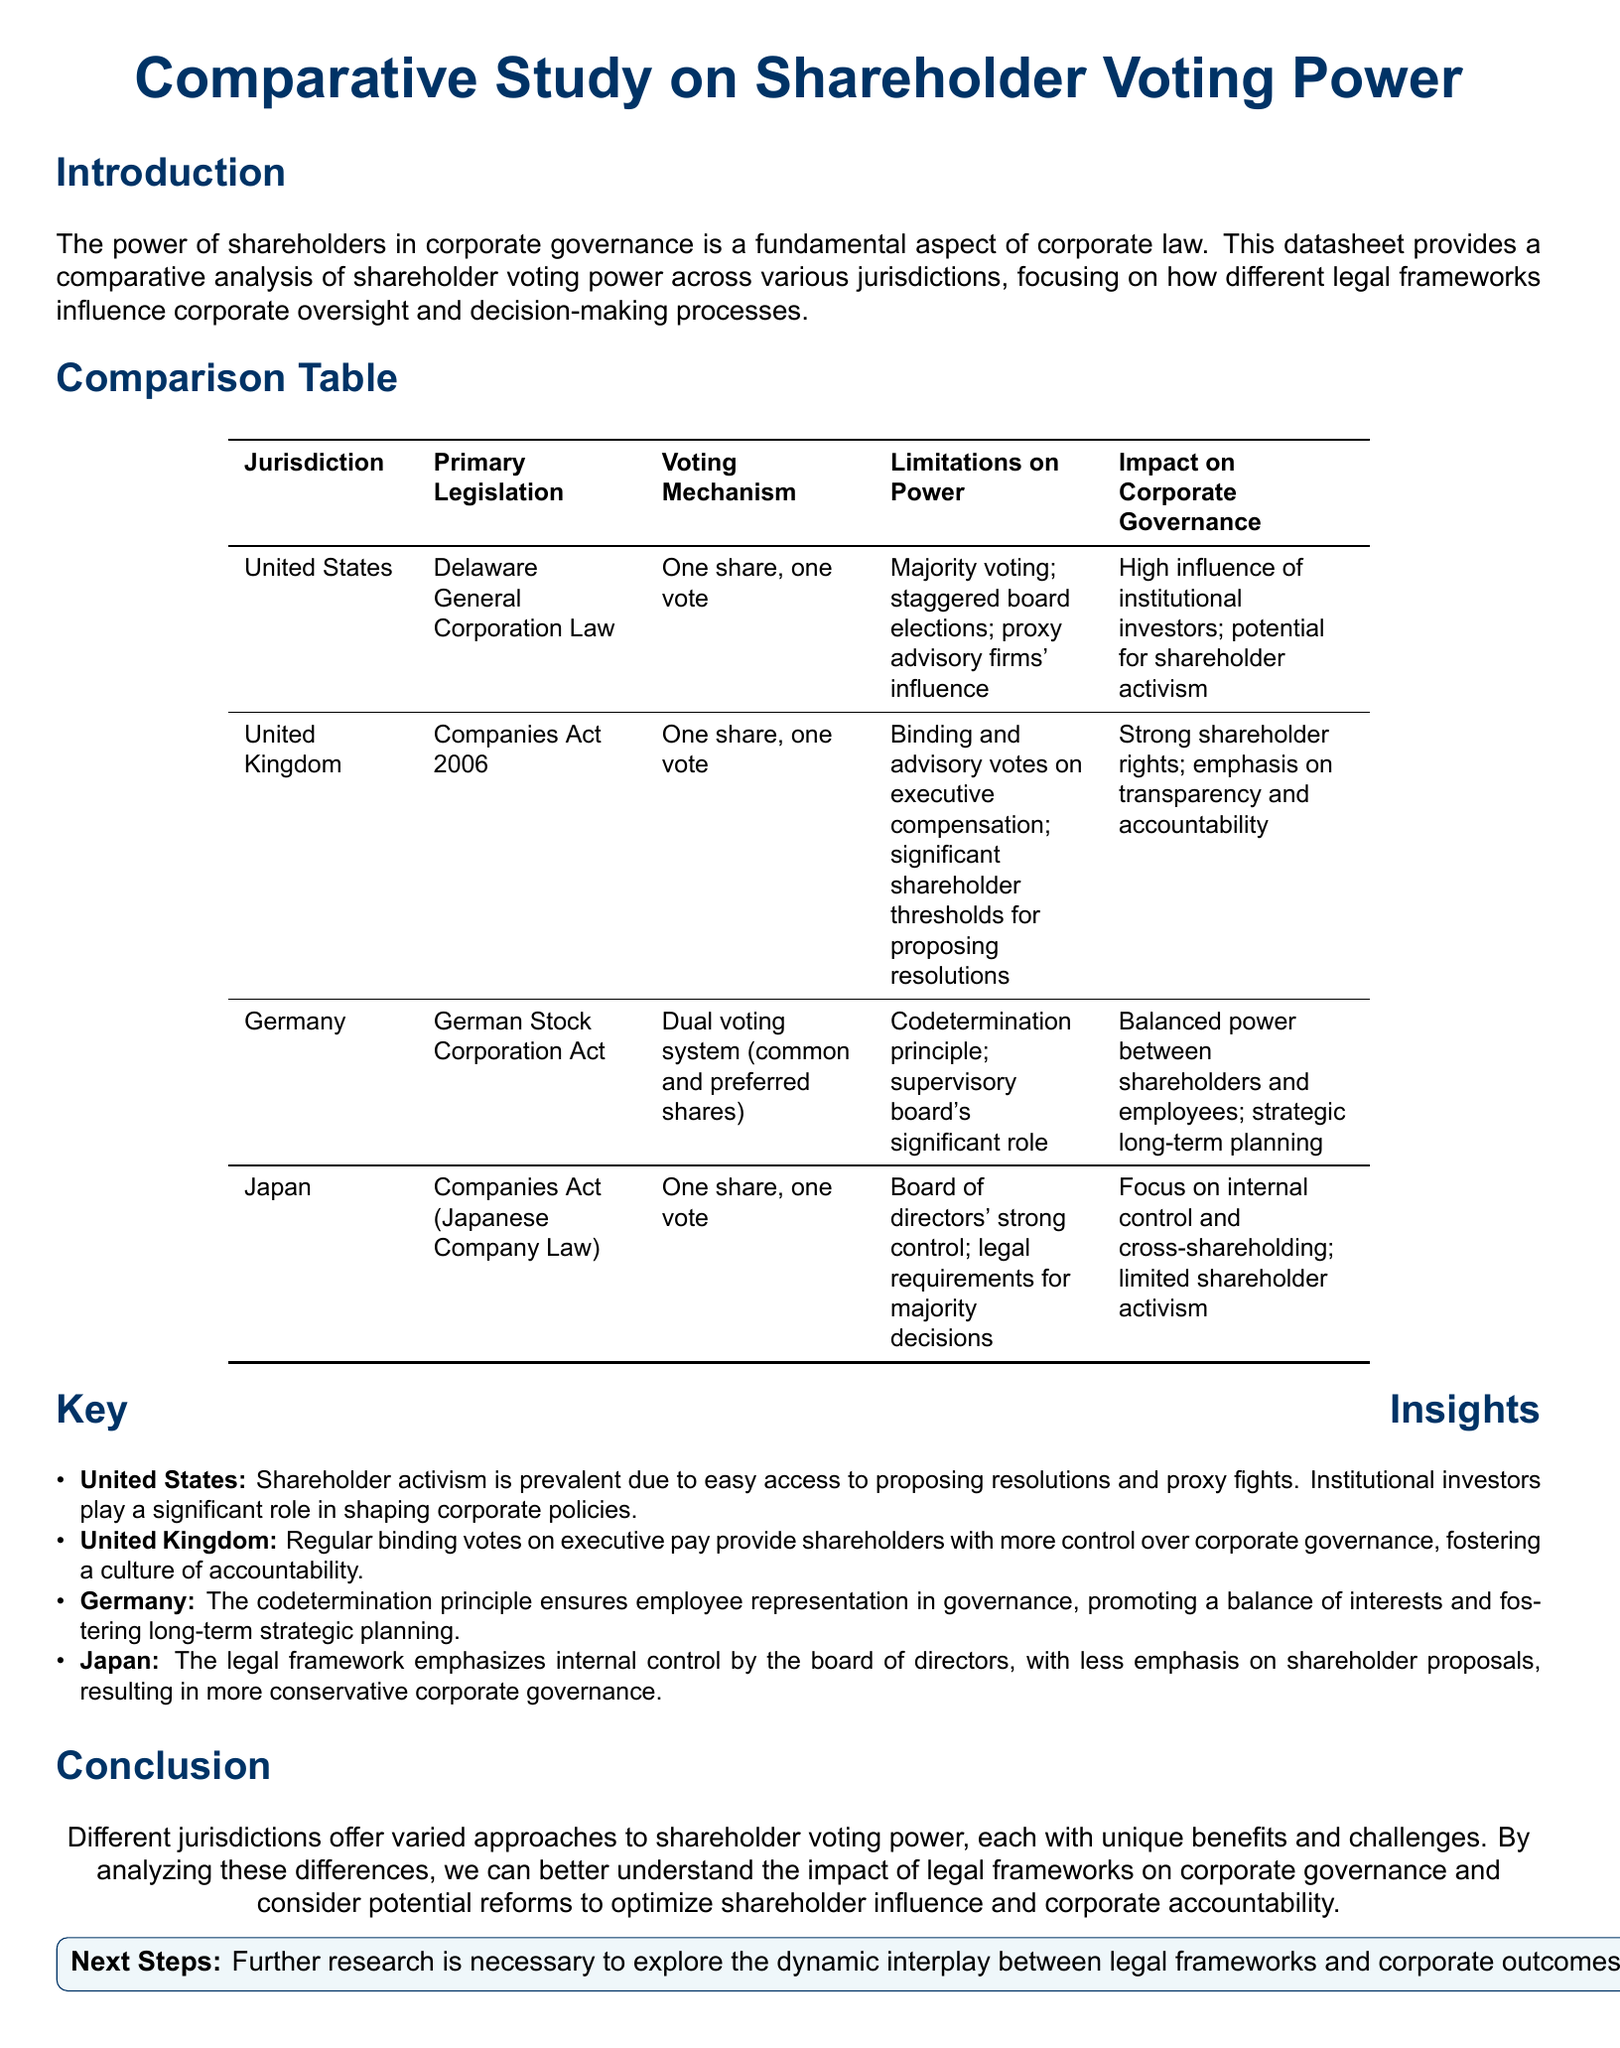what is the primary legislation in the United States? The primary legislation governing shareholder voting power in the United States is the Delaware General Corporation Law.
Answer: Delaware General Corporation Law what voting mechanism is used in Germany? Germany employs a dual voting system that includes common and preferred shares.
Answer: Dual voting system what limitation on power is present in the United Kingdom? In the United Kingdom, there are binding and advisory votes on executive compensation that limit shareholder power.
Answer: Binding and advisory votes on executive compensation which jurisdiction emphasizes internal control by the board of directors? Japan's legal framework places a strong emphasis on internal control by the board of directors.
Answer: Japan how does the German codetermination principle affect corporate governance? The codetermination principle ensures employee representation in governance, promoting a balance of interests.
Answer: Balanced power between shareholders and employees which key insight mentions institutional investors? The key insight about the United States mentions that institutional investors play a significant role in shaping corporate policies.
Answer: Shareholder activism is prevalent due to easy access to proposing resolutions and proxy fights what aspect of corporate governance does the UK Companies Act 2006 emphasize? The UK Companies Act emphasizes strong shareholder rights and transparency.
Answer: Strong shareholder rights; emphasis on transparency and accountability how does Japan's legal framework influence shareholder activism? Japan's framework results in limited shareholder activism due to the strong control of the board of directors.
Answer: Limited shareholder activism 